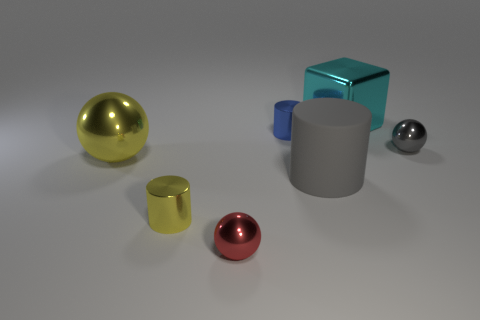What number of shiny things are purple cubes or red objects?
Make the answer very short. 1. How many large metallic objects are there?
Your answer should be very brief. 2. Does the cylinder that is behind the large yellow shiny object have the same material as the big thing in front of the yellow shiny ball?
Your answer should be very brief. No. What is the color of the other small object that is the same shape as the blue thing?
Ensure brevity in your answer.  Yellow. What is the material of the gray thing that is to the left of the big metallic object that is right of the yellow metal ball?
Your answer should be compact. Rubber. Do the large metal object left of the tiny red metal thing and the small thing that is to the right of the tiny blue metallic cylinder have the same shape?
Provide a succinct answer. Yes. There is a cylinder that is both right of the yellow cylinder and in front of the big yellow sphere; what is its size?
Provide a succinct answer. Large. How many other objects are the same color as the matte thing?
Offer a terse response. 1. Are the tiny ball in front of the yellow shiny cylinder and the small gray ball made of the same material?
Your answer should be compact. Yes. Is there any other thing that has the same size as the red shiny ball?
Your answer should be compact. Yes. 